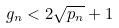Convert formula to latex. <formula><loc_0><loc_0><loc_500><loc_500>g _ { n } < 2 \sqrt { p _ { n } } + 1</formula> 